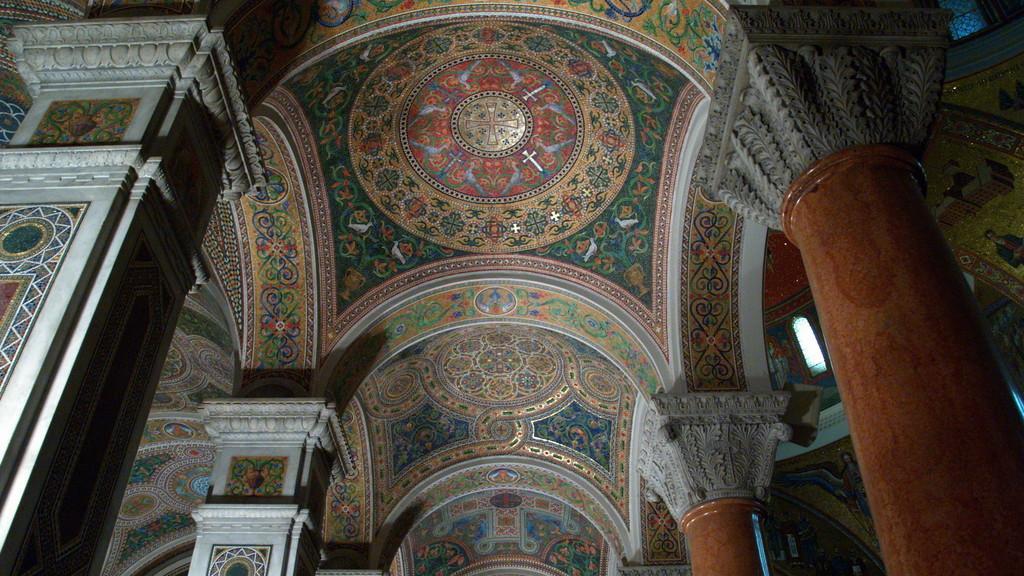In one or two sentences, can you explain what this image depicts? In the image there is a roof of a building and under the roof there are pillars. 